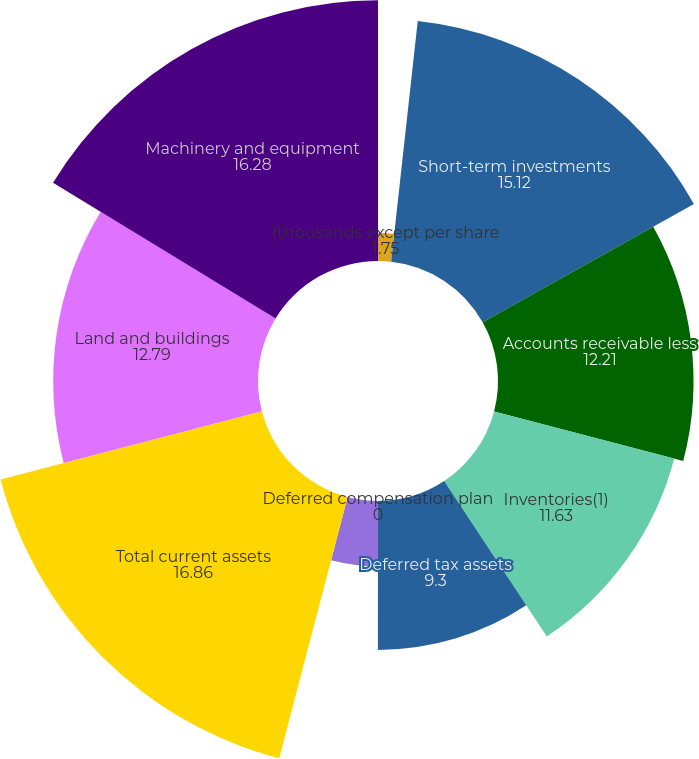Convert chart. <chart><loc_0><loc_0><loc_500><loc_500><pie_chart><fcel>(thousands except per share<fcel>Short-term investments<fcel>Accounts receivable less<fcel>Inventories(1)<fcel>Deferred tax assets<fcel>Deferred compensation plan<fcel>Prepaid expenses and other<fcel>Total current assets<fcel>Land and buildings<fcel>Machinery and equipment<nl><fcel>1.75%<fcel>15.12%<fcel>12.21%<fcel>11.63%<fcel>9.3%<fcel>0.0%<fcel>4.07%<fcel>16.86%<fcel>12.79%<fcel>16.28%<nl></chart> 